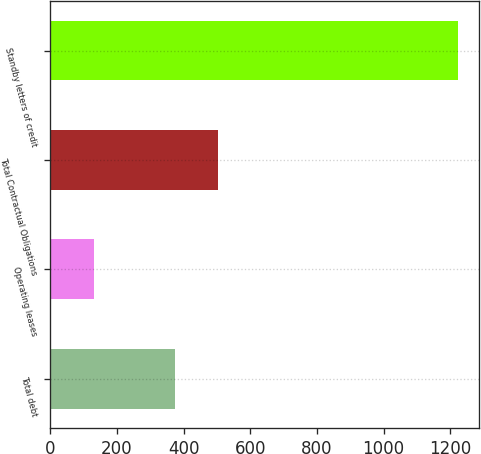Convert chart. <chart><loc_0><loc_0><loc_500><loc_500><bar_chart><fcel>Total debt<fcel>Operating leases<fcel>Total Contractual Obligations<fcel>Standby letters of credit<nl><fcel>373<fcel>130<fcel>503<fcel>1224<nl></chart> 